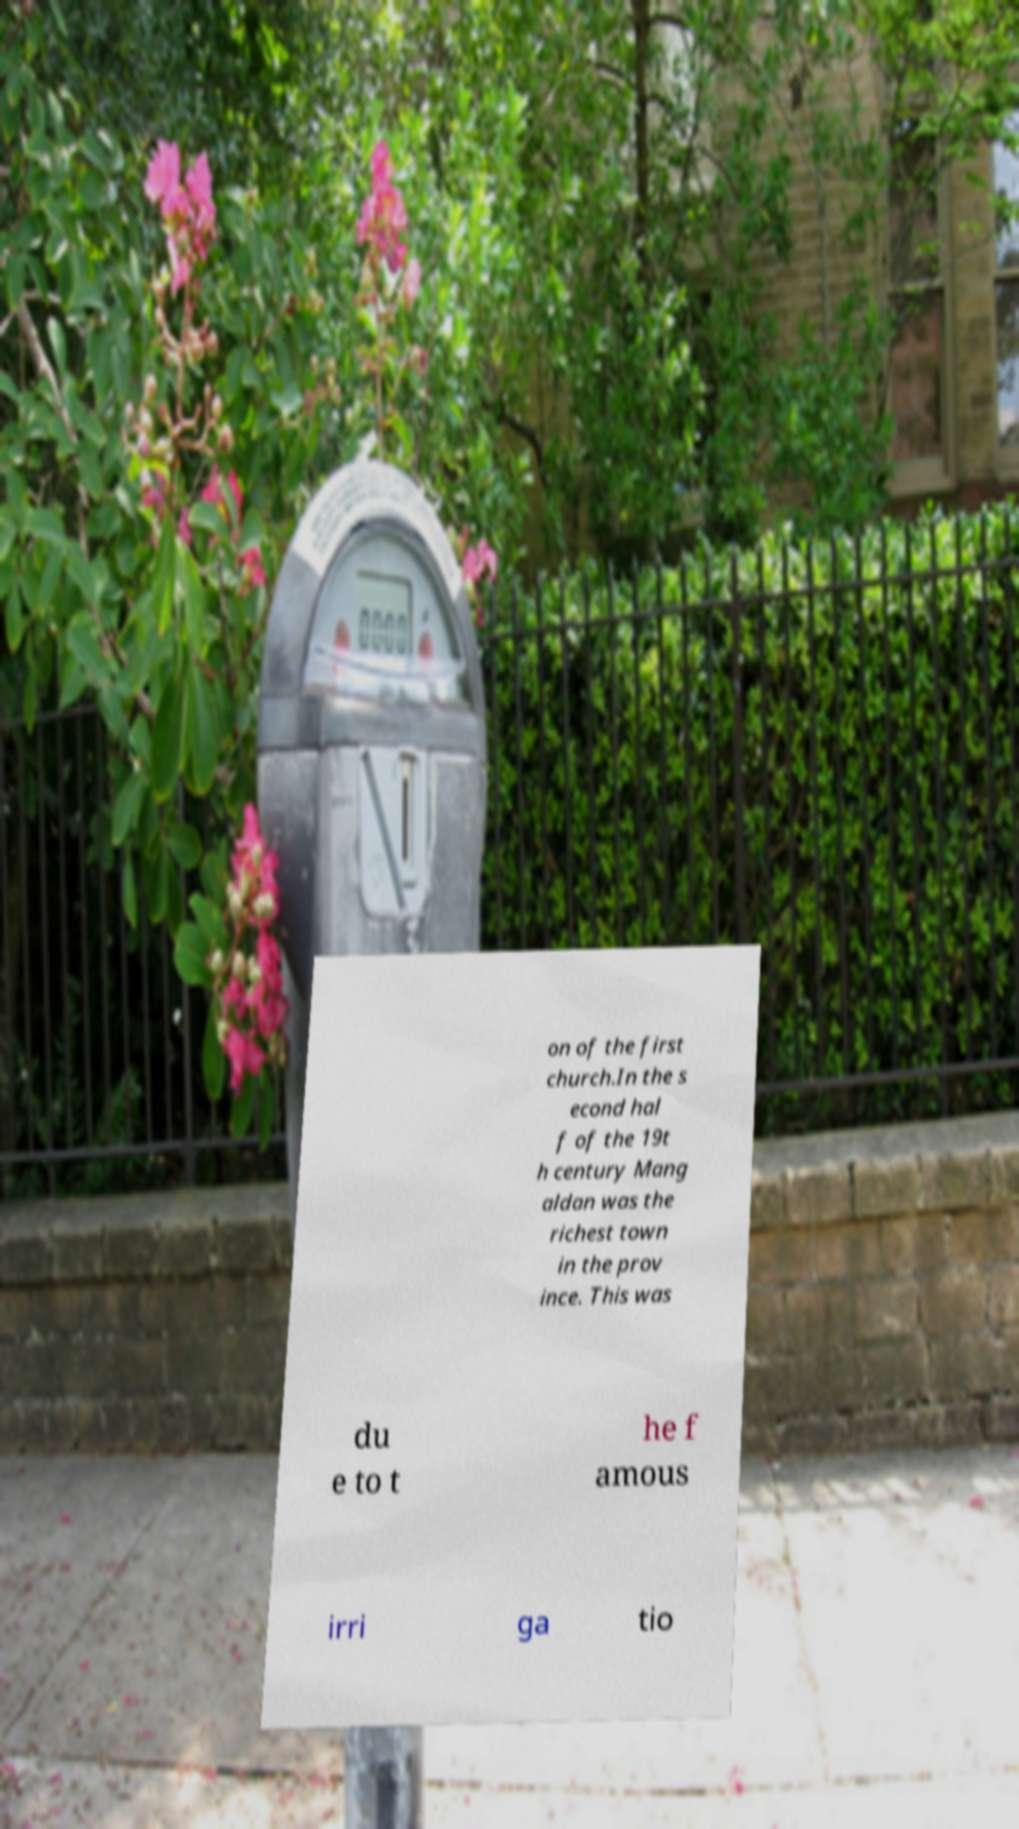Can you read and provide the text displayed in the image?This photo seems to have some interesting text. Can you extract and type it out for me? on of the first church.In the s econd hal f of the 19t h century Mang aldan was the richest town in the prov ince. This was du e to t he f amous irri ga tio 